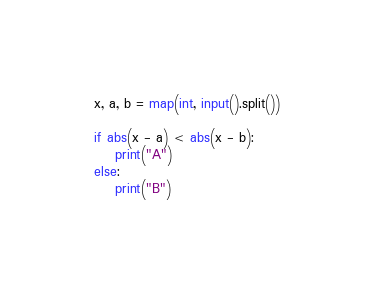Convert code to text. <code><loc_0><loc_0><loc_500><loc_500><_Python_>x, a, b = map(int, input().split())

if abs(x - a) < abs(x - b):
    print("A")
else:
    print("B")</code> 